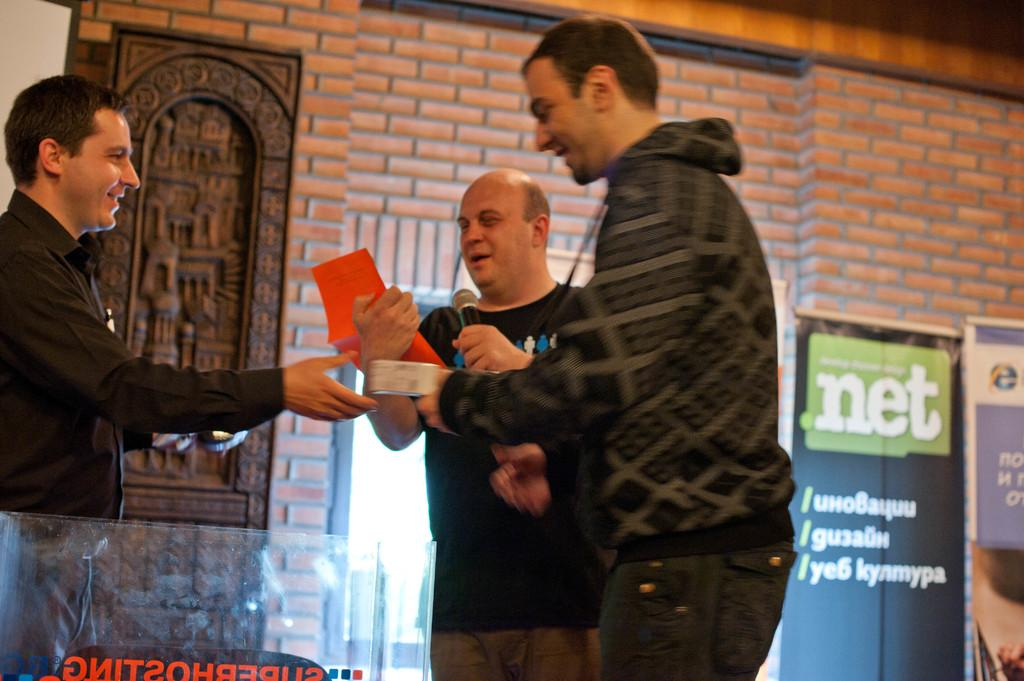How many people are in the image? There are three men in the image. What are the men doing in the image? The men are standing and smiling. What is one of the men holding in his hands? One man is holding a mic and a paper with his hands. What can be seen hanging in the image? There are banners in the image. What is visible in the background of the image? There is a wall visible in the background of the image. What type of honey is being served to the girls in the image? There are no girls or honey present in the image; it features three men standing and smiling. What type of nut is being cracked by one of the men in the image? There is no nut or nut-cracking activity depicted in the image. 